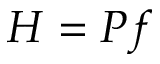Convert formula to latex. <formula><loc_0><loc_0><loc_500><loc_500>H = P f</formula> 